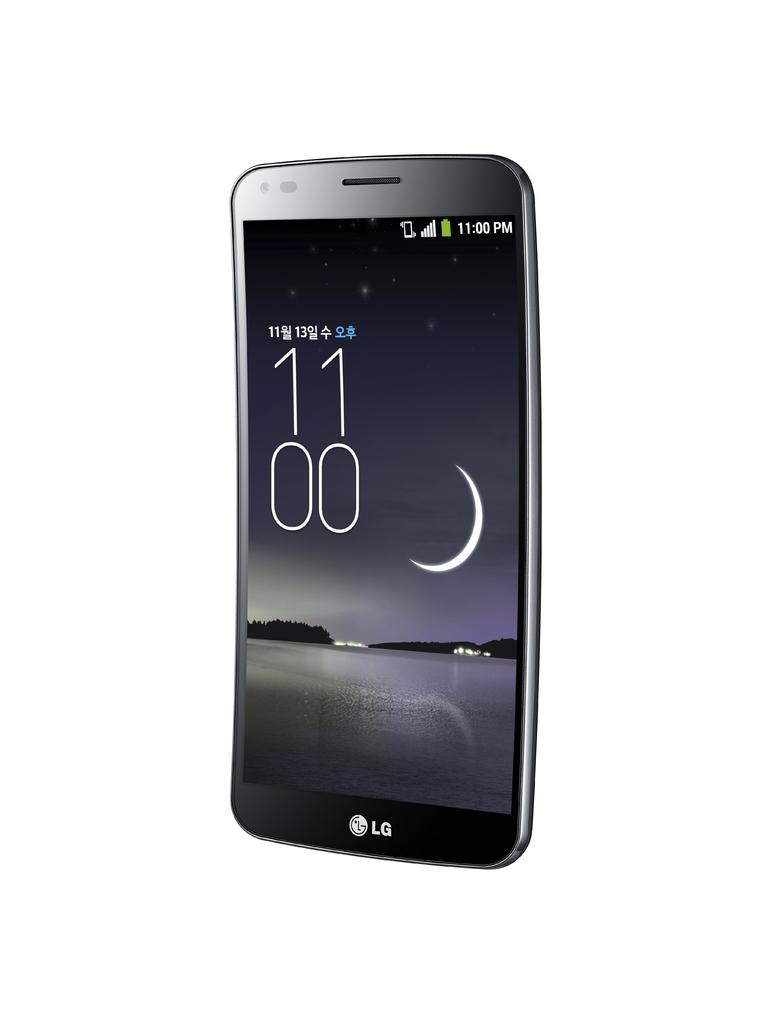<image>
Describe the image concisely. LG phone showing a wallpaper with water and a half moon, the clock is shown on the phone screen 